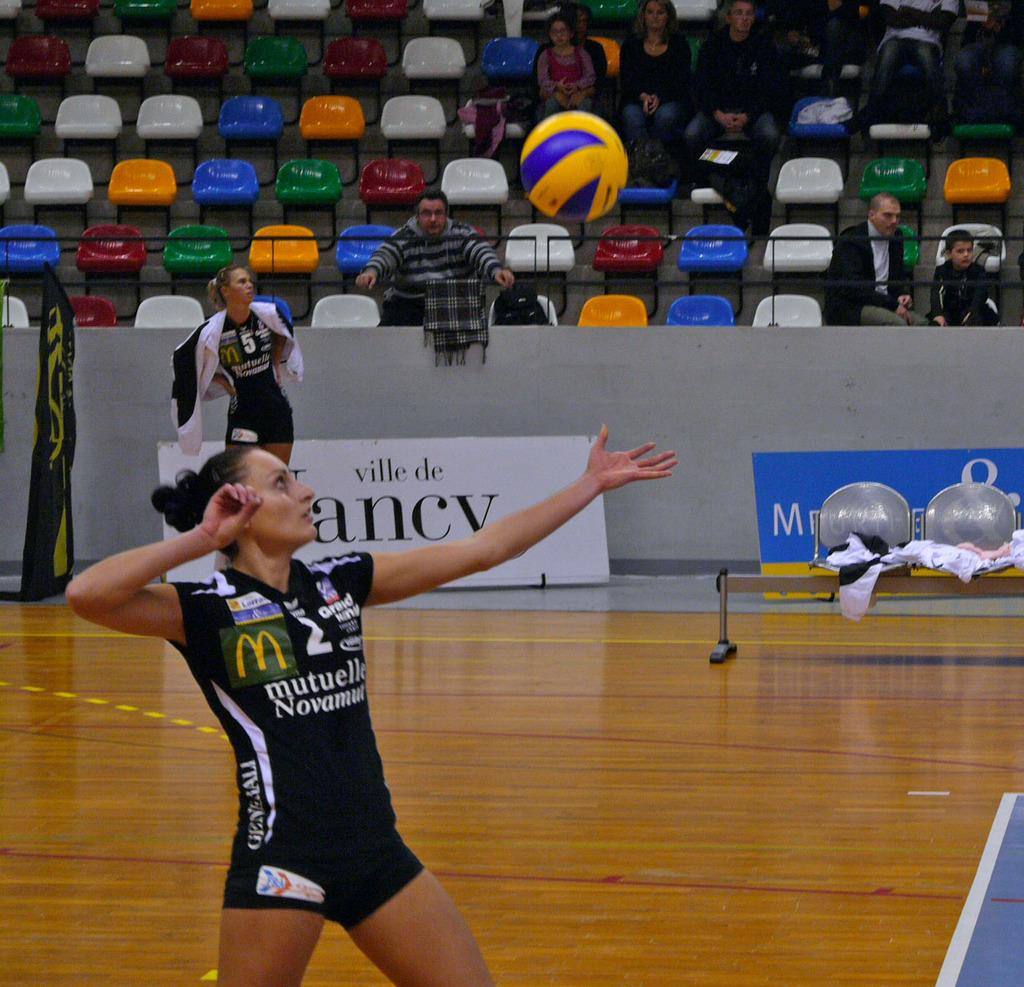<image>
Describe the image concisely. A volleyball player serves in front of an advertisement that begins with the words "ville de". 